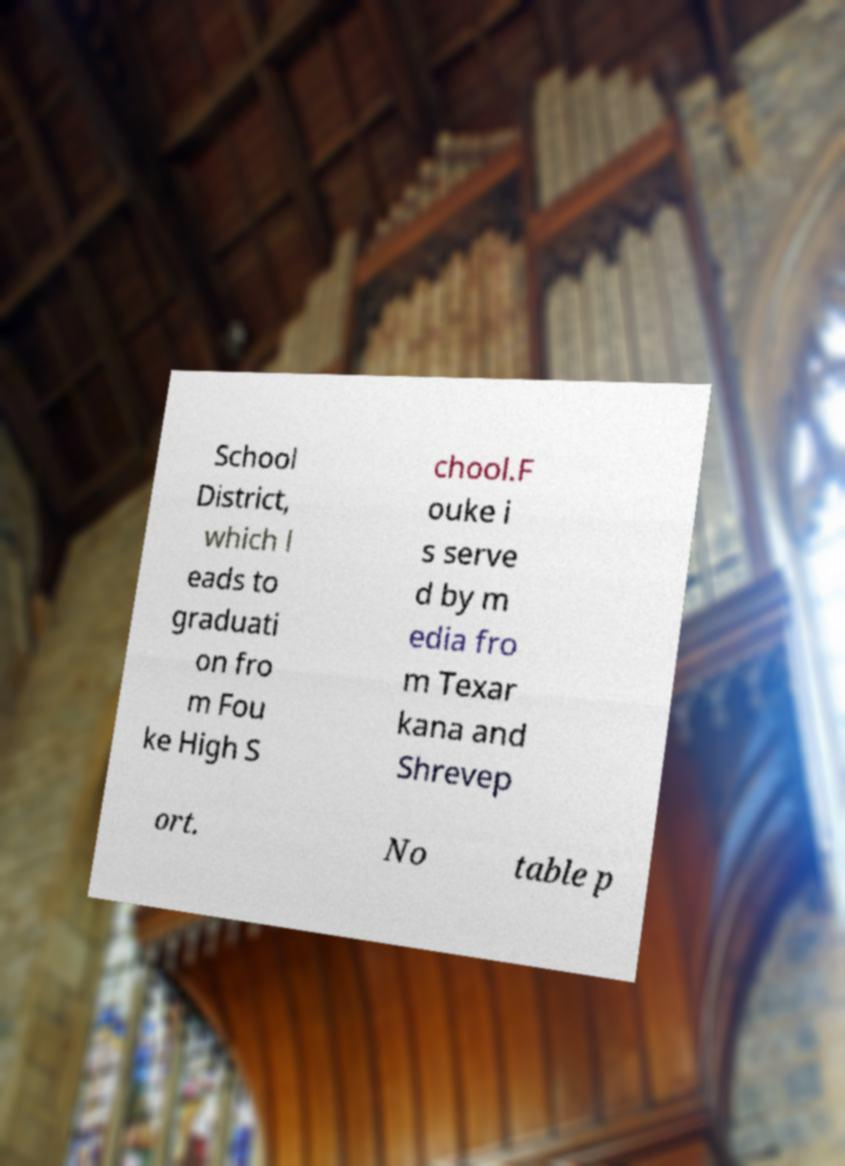Can you read and provide the text displayed in the image?This photo seems to have some interesting text. Can you extract and type it out for me? School District, which l eads to graduati on fro m Fou ke High S chool.F ouke i s serve d by m edia fro m Texar kana and Shrevep ort. No table p 